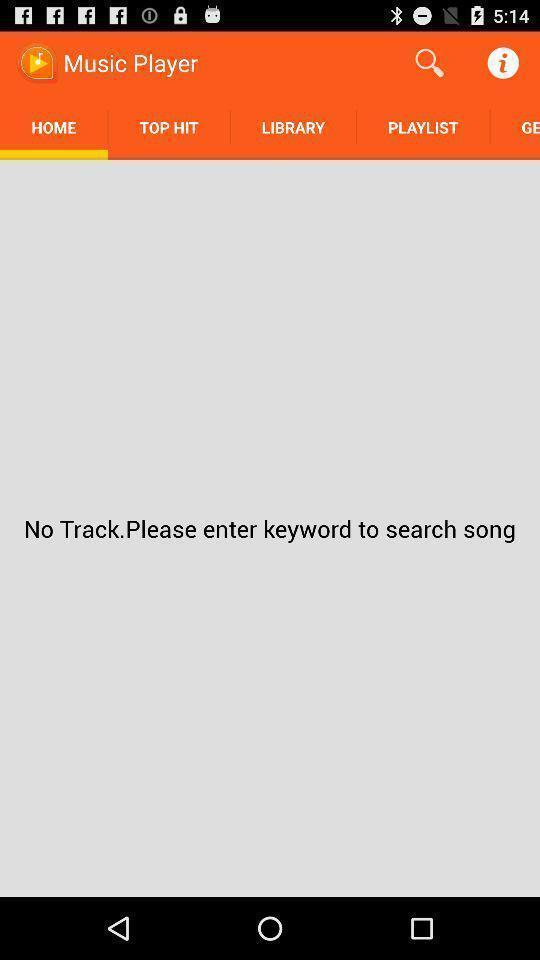Tell me about the visual elements in this screen capture. Screen shows homepage of music player app. 